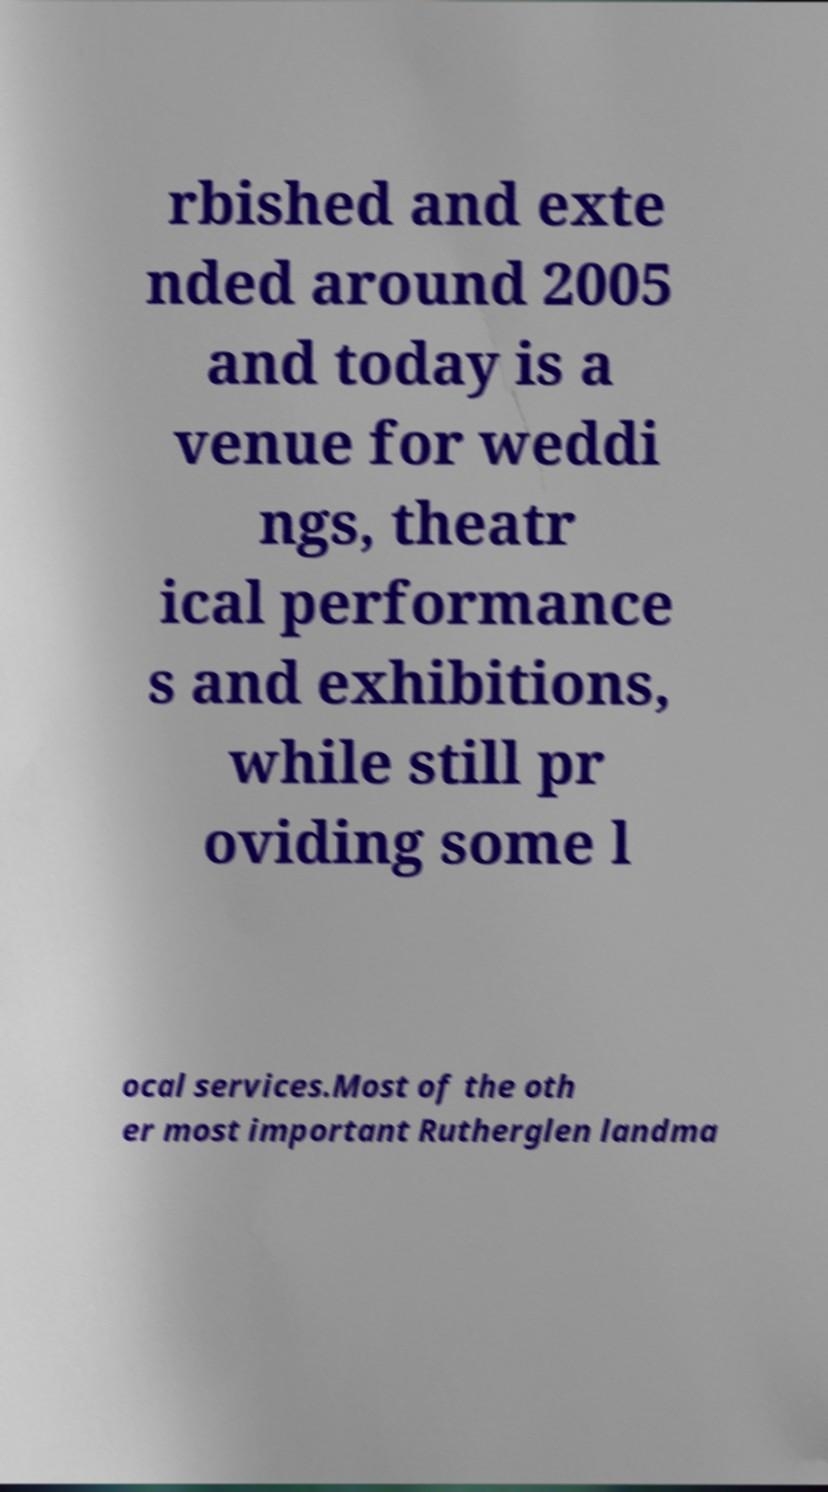Could you assist in decoding the text presented in this image and type it out clearly? rbished and exte nded around 2005 and today is a venue for weddi ngs, theatr ical performance s and exhibitions, while still pr oviding some l ocal services.Most of the oth er most important Rutherglen landma 